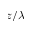<formula> <loc_0><loc_0><loc_500><loc_500>z / \lambda</formula> 